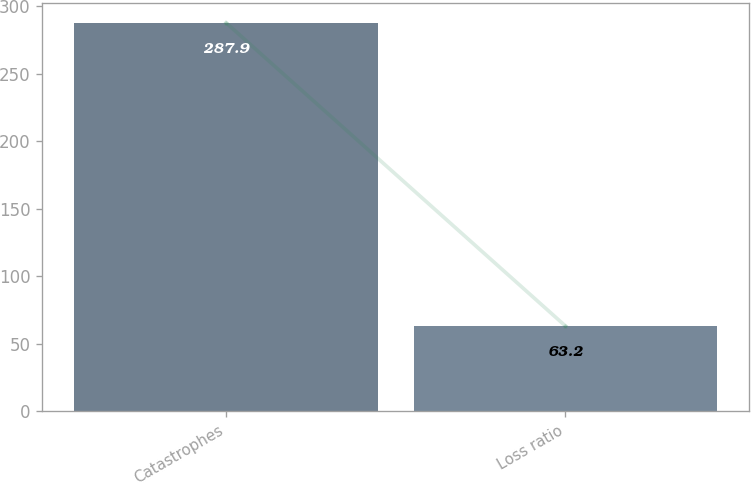Convert chart. <chart><loc_0><loc_0><loc_500><loc_500><bar_chart><fcel>Catastrophes<fcel>Loss ratio<nl><fcel>287.9<fcel>63.2<nl></chart> 